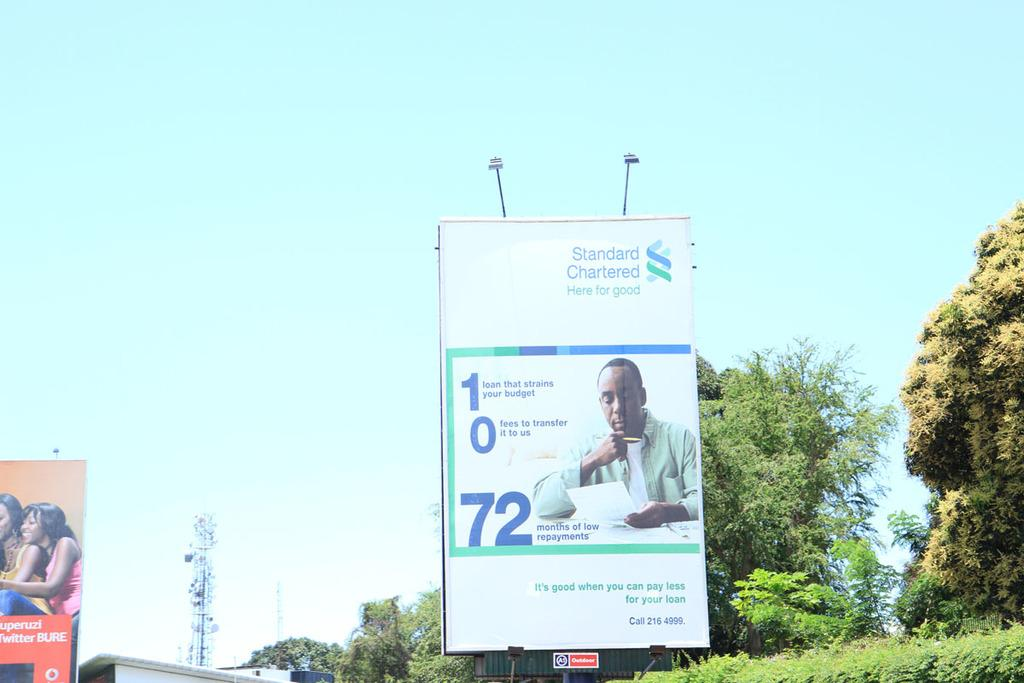<image>
Offer a succinct explanation of the picture presented. a large billboard with an advertisements for "standard chartered". 